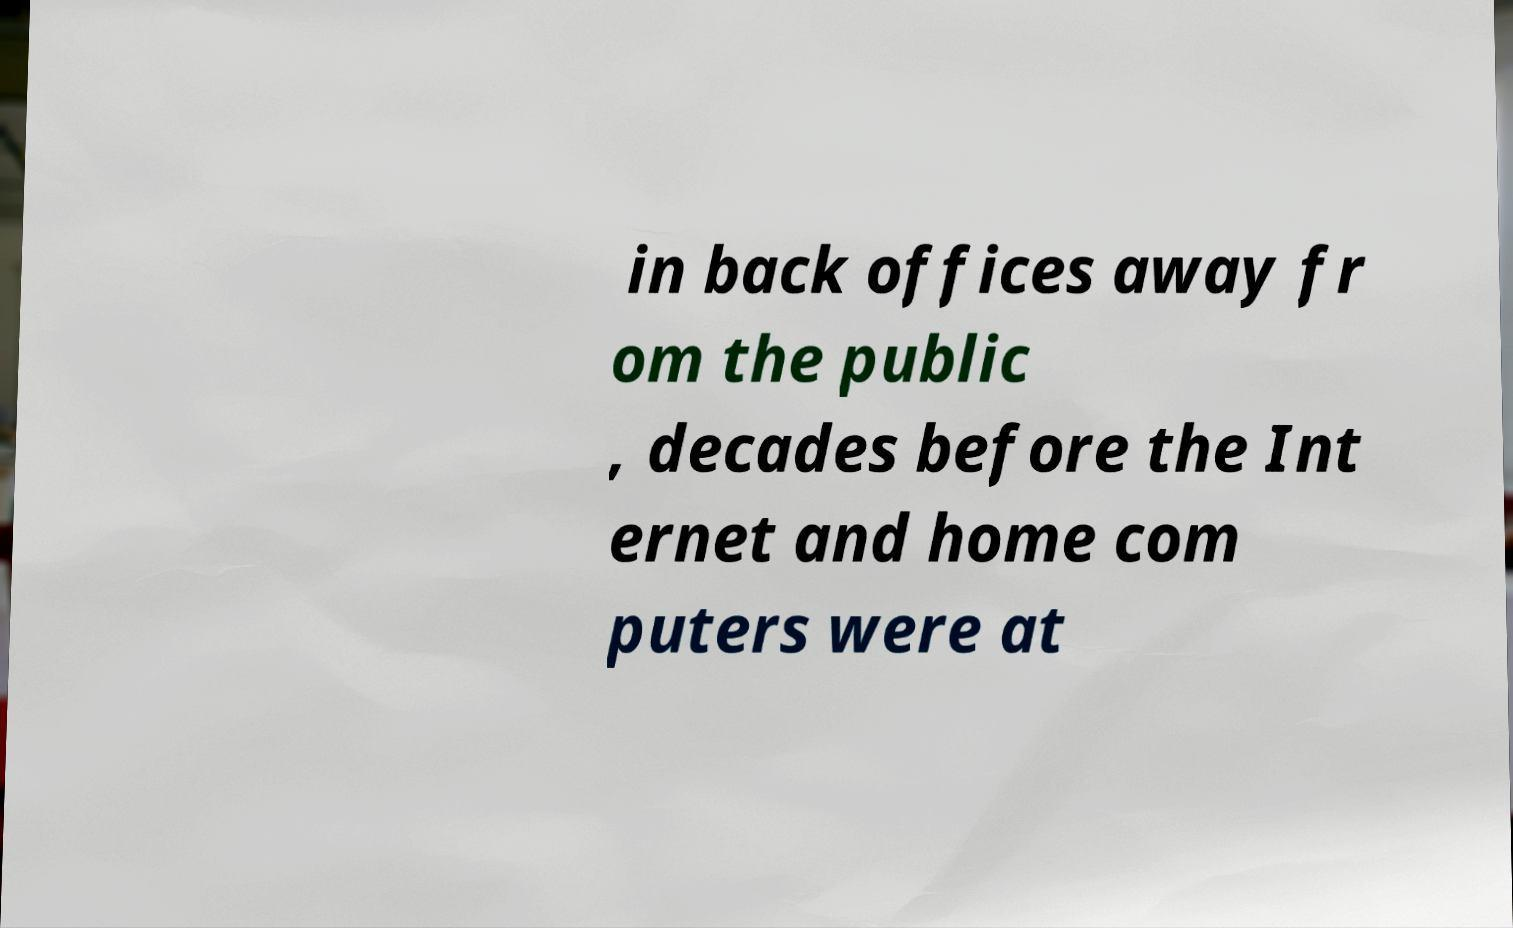Could you assist in decoding the text presented in this image and type it out clearly? in back offices away fr om the public , decades before the Int ernet and home com puters were at 